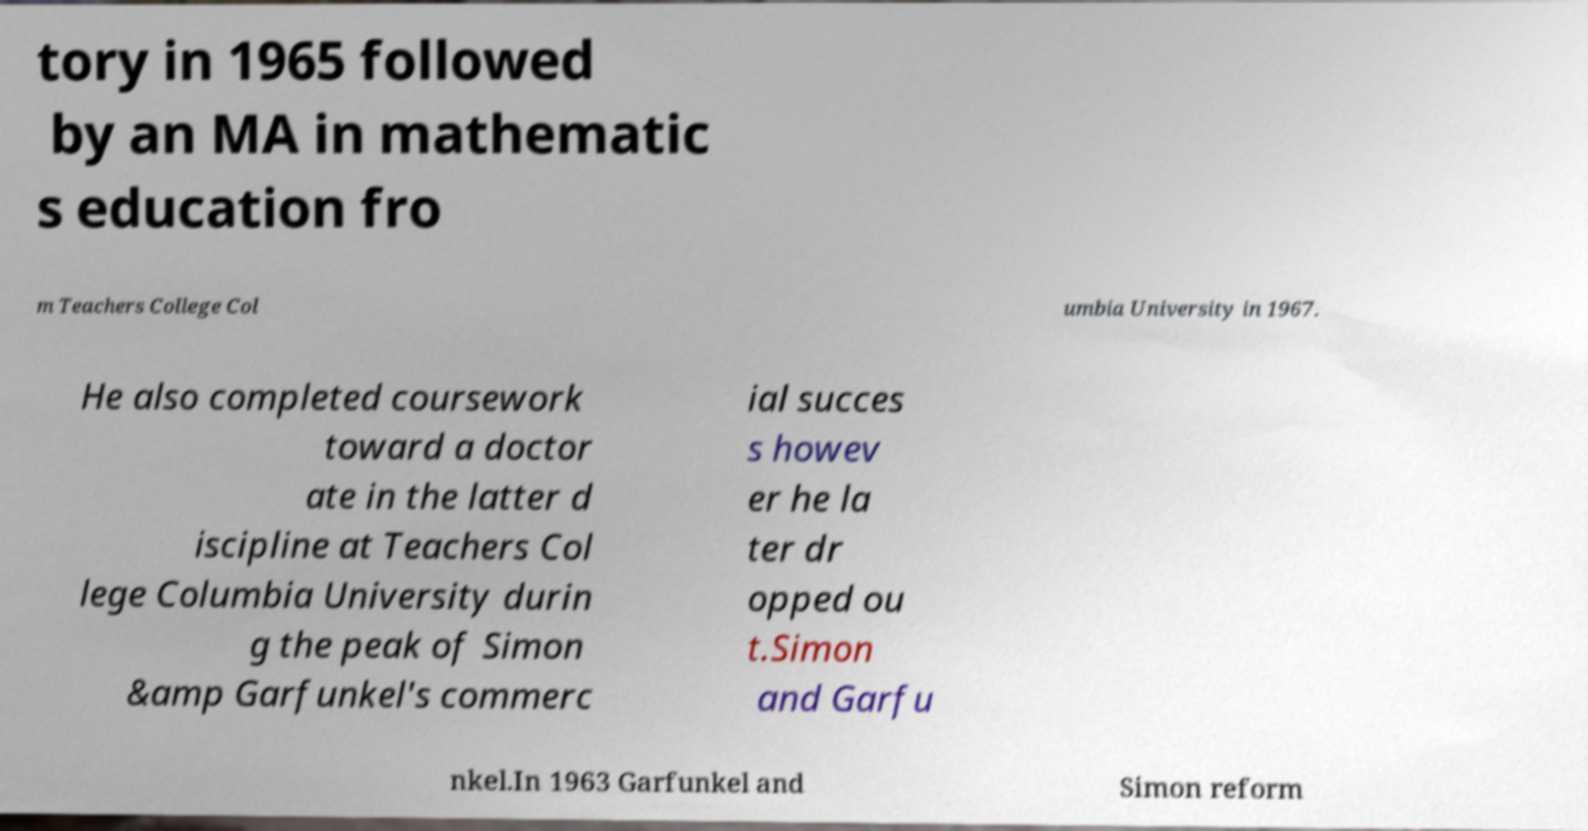Please read and relay the text visible in this image. What does it say? tory in 1965 followed by an MA in mathematic s education fro m Teachers College Col umbia University in 1967. He also completed coursework toward a doctor ate in the latter d iscipline at Teachers Col lege Columbia University durin g the peak of Simon &amp Garfunkel's commerc ial succes s howev er he la ter dr opped ou t.Simon and Garfu nkel.In 1963 Garfunkel and Simon reform 